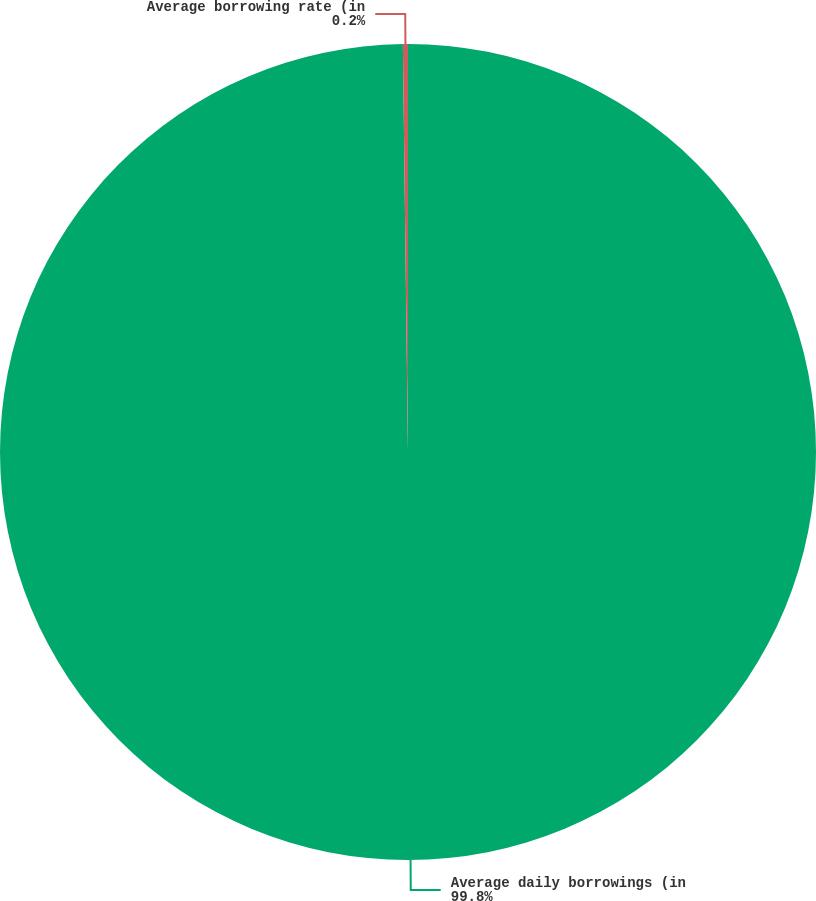Convert chart. <chart><loc_0><loc_0><loc_500><loc_500><pie_chart><fcel>Average daily borrowings (in<fcel>Average borrowing rate (in<nl><fcel>99.8%<fcel>0.2%<nl></chart> 